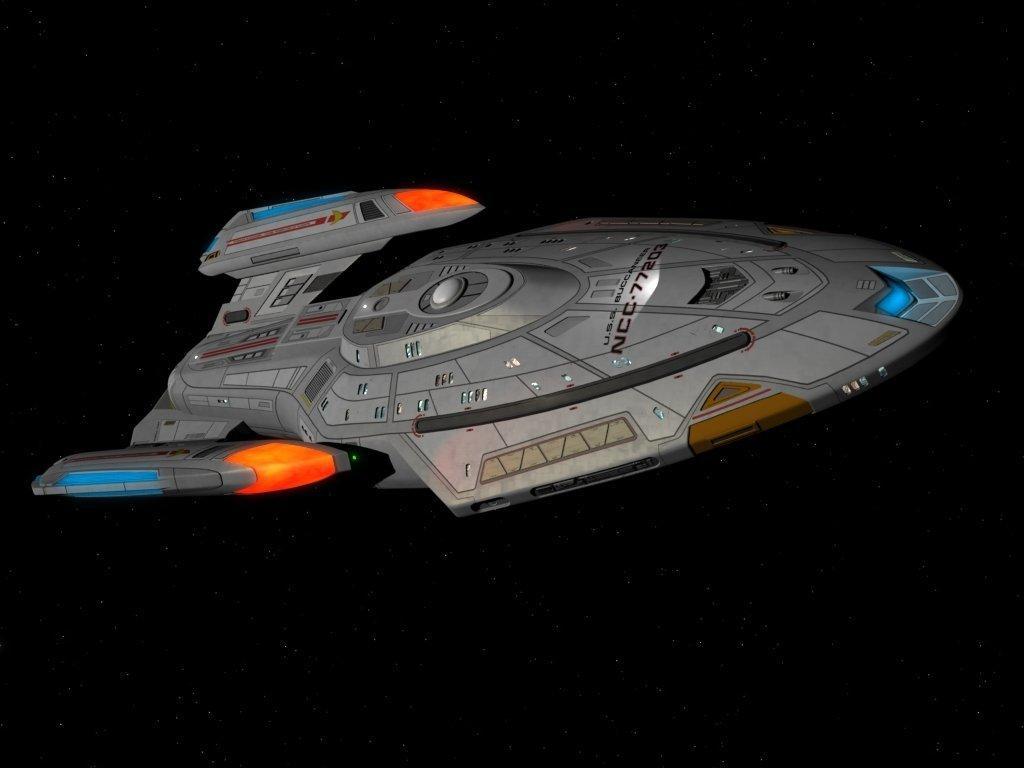How would you summarize this image in a sentence or two? In the image there is a spaceship and the background is dark. 